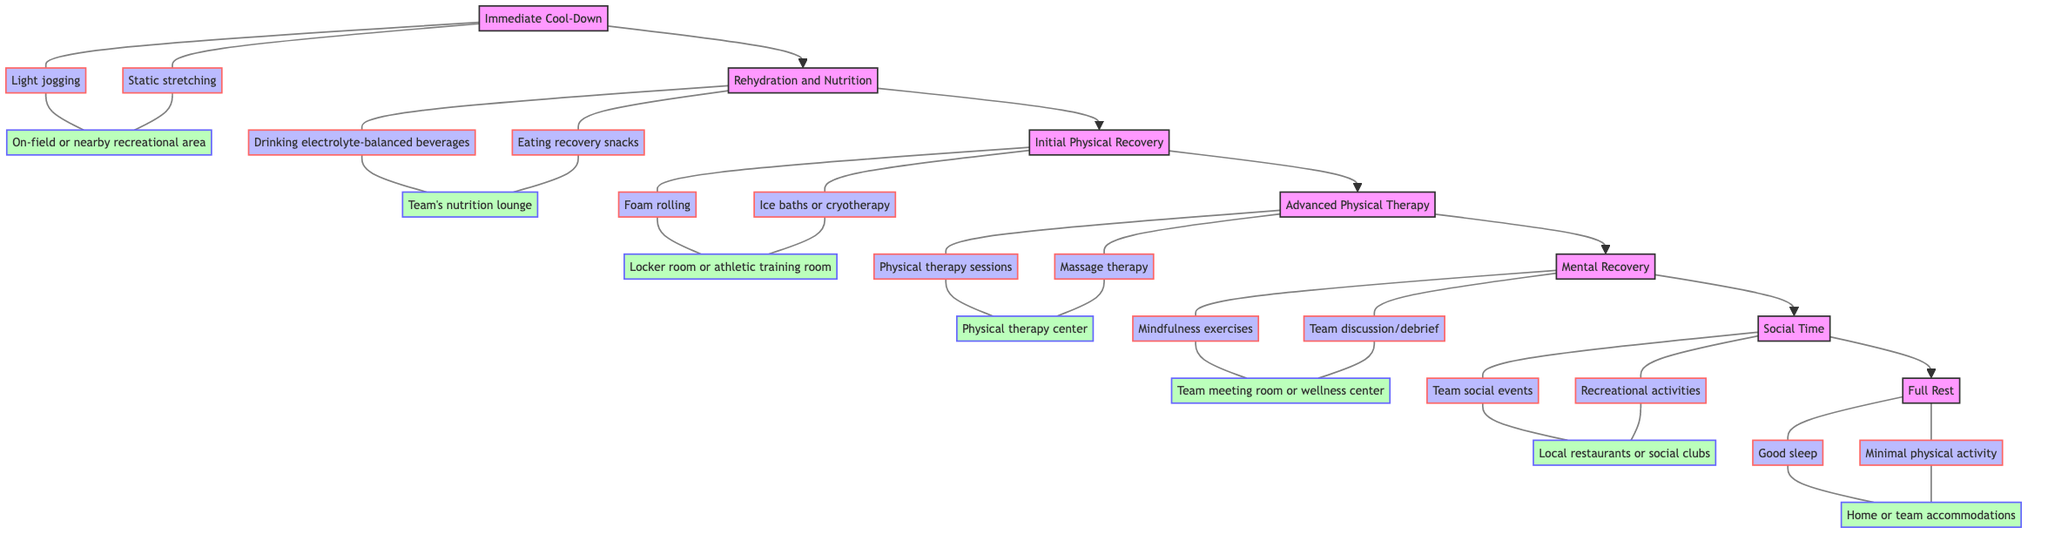What's the first step in the recovery process? The first step in the recovery process is identified as "Immediate Cool-Down," as it is the lowest node in the flow chart, indicating the starting point.
Answer: Immediate Cool-Down How many activities are listed under "Rehydration and Nutrition"? There are two activities listed under "Rehydration and Nutrition," which are "Drinking electrolyte-balanced beverages" and "Eating recovery snacks high in protein and carbs."
Answer: 2 What location is designated for "Initial Physical Recovery"? The location designated for "Initial Physical Recovery" is the "Locker room or athletic training room," as indicated under the corresponding level.
Answer: Locker room or athletic training room Which level comes directly after "Advanced Physical Therapy"? The level that comes directly after "Advanced Physical Therapy" is "Mental Recovery," following the upward flow structure of the chart.
Answer: Mental Recovery What is the final step in the recovery process? The final step in the recovery process is "Full Rest," as it is the highest level in the flow chart, indicating it is the concluding stage of recovery.
Answer: Full Rest How many total levels are there in the recovery process? There are a total of seven levels in the recovery process, as counted from "Immediate Cool-Down" to "Full Rest."
Answer: 7 Which activity is unique to the "Social Time" level? The activity unique to the "Social Time" level is "Team social events," distinguishing it from other recovery stages which focus more on physical or mental activities.
Answer: Team social events What is the primary focus of the "Mental Recovery" level? The primary focus of the "Mental Recovery" level includes activities such as "Mindfulness exercises" and "Team discussion/debrief," emphasizing the mental aspect of recovery.
Answer: Mindfulness exercises, Team discussion/debrief What type of chart is being used to display the recovery process? The type of chart used to display the recovery process is a "Bottom to Top Flow Chart," characterized by the direction of the arrows pointing upward.
Answer: Bottom to Top Flow Chart 